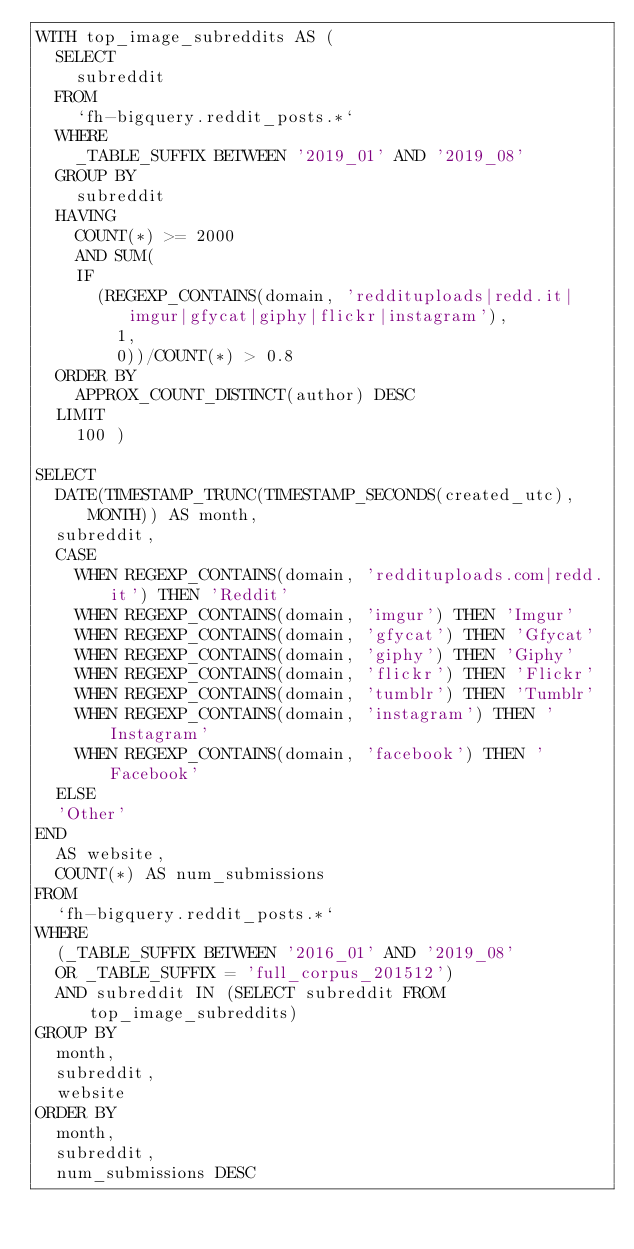<code> <loc_0><loc_0><loc_500><loc_500><_SQL_>WITH top_image_subreddits AS (
  SELECT
    subreddit
  FROM
    `fh-bigquery.reddit_posts.*`
  WHERE
    _TABLE_SUFFIX BETWEEN '2019_01' AND '2019_08'
  GROUP BY
    subreddit
  HAVING
    COUNT(*) >= 2000
    AND SUM(
    IF
      (REGEXP_CONTAINS(domain, 'reddituploads|redd.it|imgur|gfycat|giphy|flickr|instagram'),
        1,
        0))/COUNT(*) > 0.8
  ORDER BY
    APPROX_COUNT_DISTINCT(author) DESC
  LIMIT
    100 )
    
SELECT
  DATE(TIMESTAMP_TRUNC(TIMESTAMP_SECONDS(created_utc), MONTH)) AS month,
  subreddit,
  CASE
    WHEN REGEXP_CONTAINS(domain, 'reddituploads.com|redd.it') THEN 'Reddit'
    WHEN REGEXP_CONTAINS(domain, 'imgur') THEN 'Imgur'
    WHEN REGEXP_CONTAINS(domain, 'gfycat') THEN 'Gfycat'
    WHEN REGEXP_CONTAINS(domain, 'giphy') THEN 'Giphy'
    WHEN REGEXP_CONTAINS(domain, 'flickr') THEN 'Flickr'
    WHEN REGEXP_CONTAINS(domain, 'tumblr') THEN 'Tumblr'
    WHEN REGEXP_CONTAINS(domain, 'instagram') THEN 'Instagram'
    WHEN REGEXP_CONTAINS(domain, 'facebook') THEN 'Facebook'
  ELSE
  'Other'
END
  AS website,
  COUNT(*) AS num_submissions
FROM
  `fh-bigquery.reddit_posts.*`
WHERE
  (_TABLE_SUFFIX BETWEEN '2016_01' AND '2019_08' 
  OR _TABLE_SUFFIX = 'full_corpus_201512')
  AND subreddit IN (SELECT subreddit FROM top_image_subreddits)
GROUP BY
  month,
  subreddit,
  website
ORDER BY
  month,
  subreddit,
  num_submissions DESC

</code> 